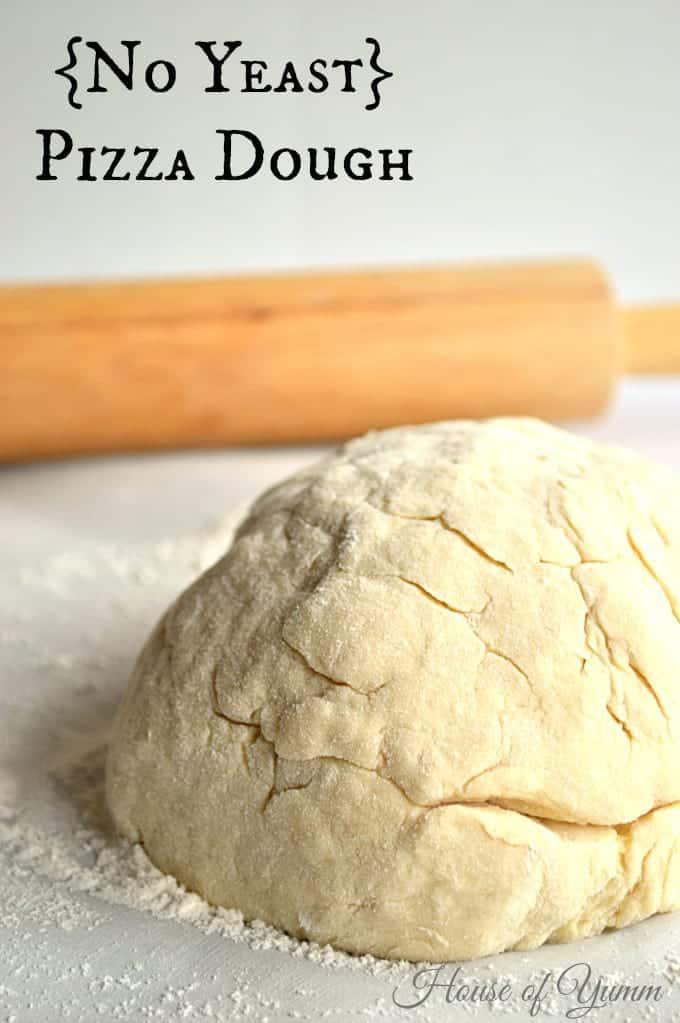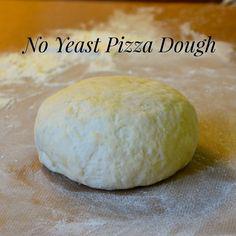The first image is the image on the left, the second image is the image on the right. For the images displayed, is the sentence "One image shows a round ball of dough on a white plate that rests on a white cloth, and the other image shows a flattened round dough shape." factually correct? Answer yes or no. No. 